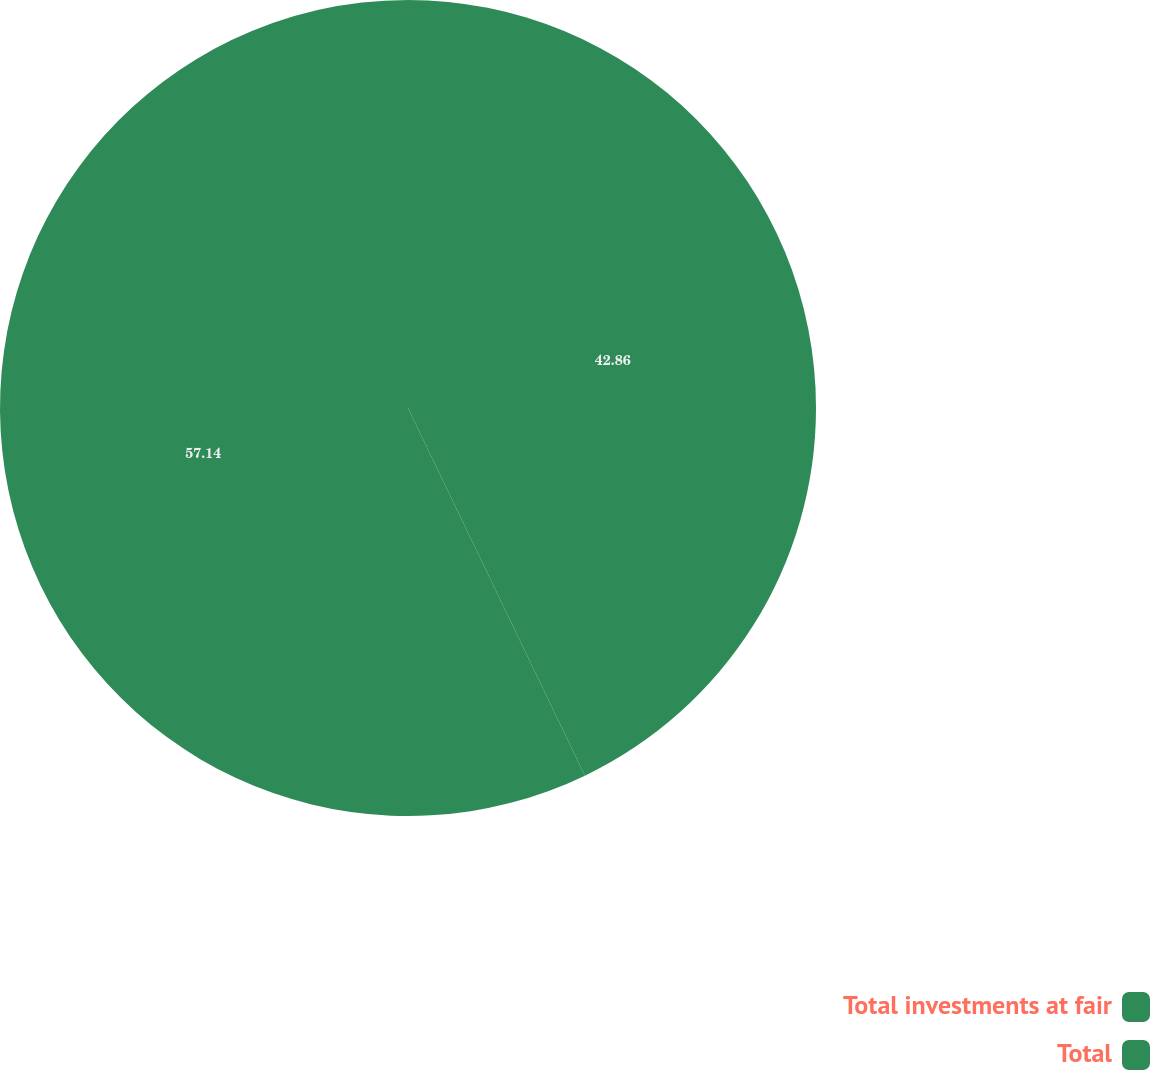<chart> <loc_0><loc_0><loc_500><loc_500><pie_chart><fcel>Total investments at fair<fcel>Total<nl><fcel>42.86%<fcel>57.14%<nl></chart> 